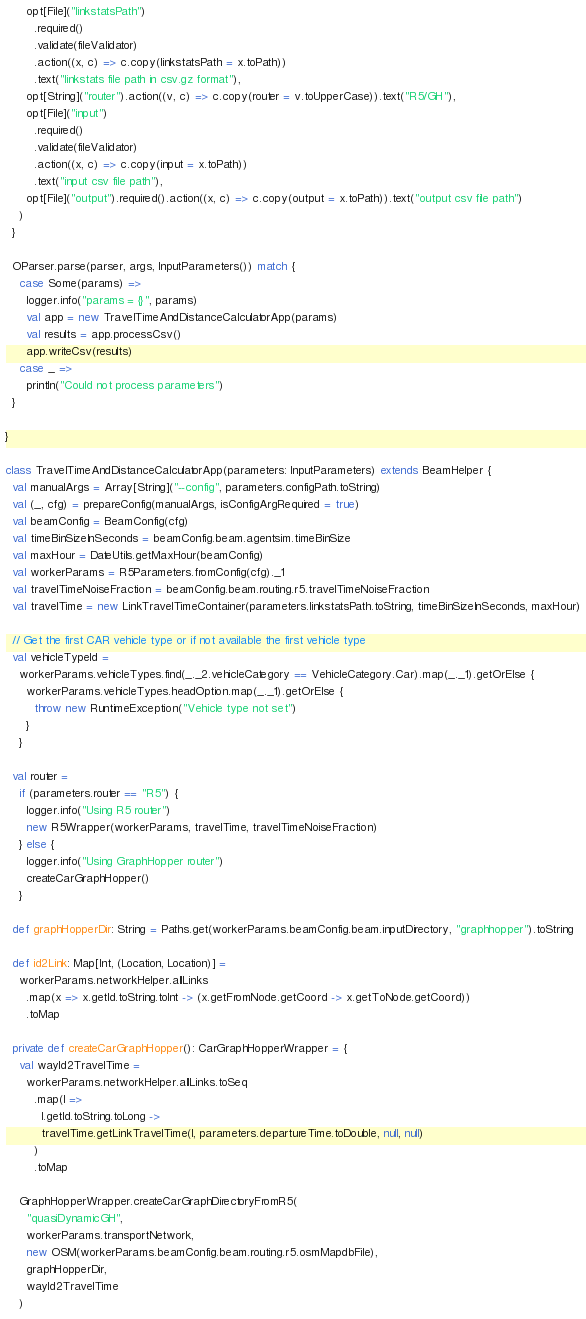<code> <loc_0><loc_0><loc_500><loc_500><_Scala_>      opt[File]("linkstatsPath")
        .required()
        .validate(fileValidator)
        .action((x, c) => c.copy(linkstatsPath = x.toPath))
        .text("linkstats file path in csv.gz format"),
      opt[String]("router").action((v, c) => c.copy(router = v.toUpperCase)).text("R5/GH"),
      opt[File]("input")
        .required()
        .validate(fileValidator)
        .action((x, c) => c.copy(input = x.toPath))
        .text("input csv file path"),
      opt[File]("output").required().action((x, c) => c.copy(output = x.toPath)).text("output csv file path")
    )
  }

  OParser.parse(parser, args, InputParameters()) match {
    case Some(params) =>
      logger.info("params = {}", params)
      val app = new TravelTimeAndDistanceCalculatorApp(params)
      val results = app.processCsv()
      app.writeCsv(results)
    case _ =>
      println("Could not process parameters")
  }

}

class TravelTimeAndDistanceCalculatorApp(parameters: InputParameters) extends BeamHelper {
  val manualArgs = Array[String]("--config", parameters.configPath.toString)
  val (_, cfg) = prepareConfig(manualArgs, isConfigArgRequired = true)
  val beamConfig = BeamConfig(cfg)
  val timeBinSizeInSeconds = beamConfig.beam.agentsim.timeBinSize
  val maxHour = DateUtils.getMaxHour(beamConfig)
  val workerParams = R5Parameters.fromConfig(cfg)._1
  val travelTimeNoiseFraction = beamConfig.beam.routing.r5.travelTimeNoiseFraction
  val travelTime = new LinkTravelTimeContainer(parameters.linkstatsPath.toString, timeBinSizeInSeconds, maxHour)

  // Get the first CAR vehicle type or if not available the first vehicle type
  val vehicleTypeId =
    workerParams.vehicleTypes.find(_._2.vehicleCategory == VehicleCategory.Car).map(_._1).getOrElse {
      workerParams.vehicleTypes.headOption.map(_._1).getOrElse {
        throw new RuntimeException("Vehicle type not set")
      }
    }

  val router =
    if (parameters.router == "R5") {
      logger.info("Using R5 router")
      new R5Wrapper(workerParams, travelTime, travelTimeNoiseFraction)
    } else {
      logger.info("Using GraphHopper router")
      createCarGraphHopper()
    }

  def graphHopperDir: String = Paths.get(workerParams.beamConfig.beam.inputDirectory, "graphhopper").toString

  def id2Link: Map[Int, (Location, Location)] =
    workerParams.networkHelper.allLinks
      .map(x => x.getId.toString.toInt -> (x.getFromNode.getCoord -> x.getToNode.getCoord))
      .toMap

  private def createCarGraphHopper(): CarGraphHopperWrapper = {
    val wayId2TravelTime =
      workerParams.networkHelper.allLinks.toSeq
        .map(l =>
          l.getId.toString.toLong ->
          travelTime.getLinkTravelTime(l, parameters.departureTime.toDouble, null, null)
        )
        .toMap

    GraphHopperWrapper.createCarGraphDirectoryFromR5(
      "quasiDynamicGH",
      workerParams.transportNetwork,
      new OSM(workerParams.beamConfig.beam.routing.r5.osmMapdbFile),
      graphHopperDir,
      wayId2TravelTime
    )
</code> 